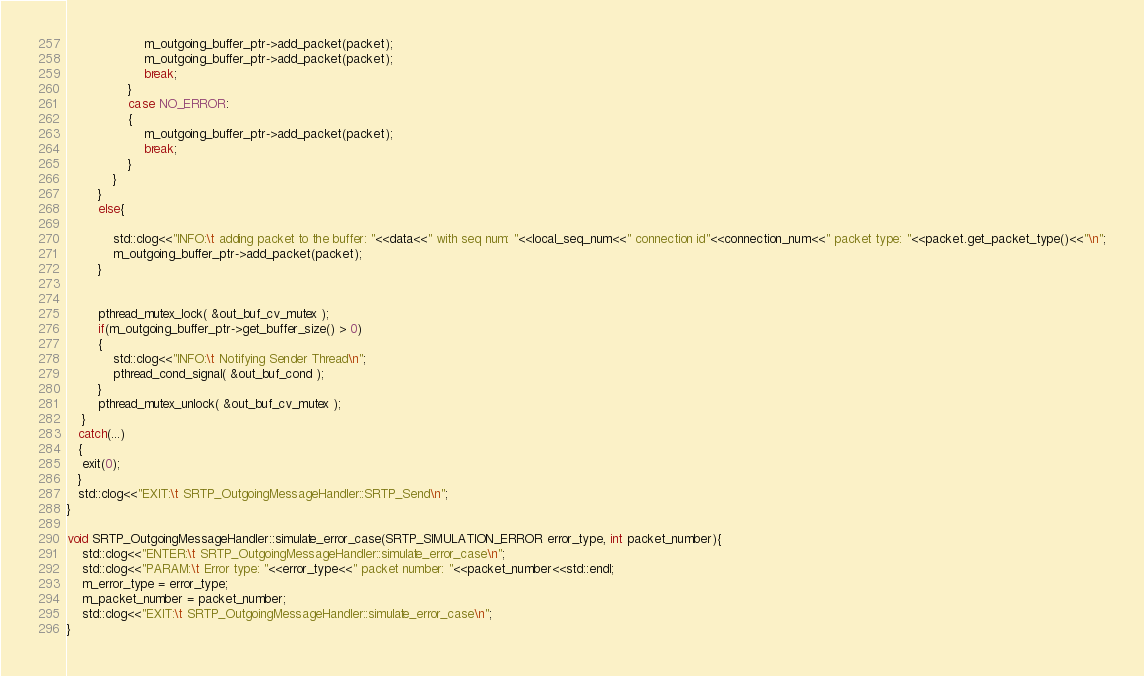Convert code to text. <code><loc_0><loc_0><loc_500><loc_500><_C++_>					m_outgoing_buffer_ptr->add_packet(packet);
					m_outgoing_buffer_ptr->add_packet(packet);
					break;
				}
				case NO_ERROR:
				{
					m_outgoing_buffer_ptr->add_packet(packet);
					break;
				}
			}
		}
		else{

			std::clog<<"INFO:\t adding packet to the buffer: "<<data<<" with seq num: "<<local_seq_num<<" connection id"<<connection_num<<" packet type: "<<packet.get_packet_type()<<"\n";
			m_outgoing_buffer_ptr->add_packet(packet);
		}


		pthread_mutex_lock( &out_buf_cv_mutex );
 		if(m_outgoing_buffer_ptr->get_buffer_size() > 0)
        {
	        std::clog<<"INFO:\t Notifying Sender Thread\n";
			pthread_cond_signal( &out_buf_cond );
		}
		pthread_mutex_unlock( &out_buf_cv_mutex );
	}
   catch(...)
   {
	exit(0);
   }
   std::clog<<"EXIT:\t SRTP_OutgoingMessageHandler::SRTP_Send\n";
}
void SRTP_OutgoingMessageHandler::simulate_error_case(SRTP_SIMULATION_ERROR error_type, int packet_number){
	std::clog<<"ENTER:\t SRTP_OutgoingMessageHandler::simulate_error_case\n";
	std::clog<<"PARAM:\t Error type: "<<error_type<<" packet number: "<<packet_number<<std::endl;
	m_error_type = error_type;
	m_packet_number = packet_number;	
	std::clog<<"EXIT:\t SRTP_OutgoingMessageHandler::simulate_error_case\n";
}
</code> 